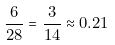Convert formula to latex. <formula><loc_0><loc_0><loc_500><loc_500>\frac { 6 } { 2 8 } = \frac { 3 } { 1 4 } \approx 0 . 2 1</formula> 